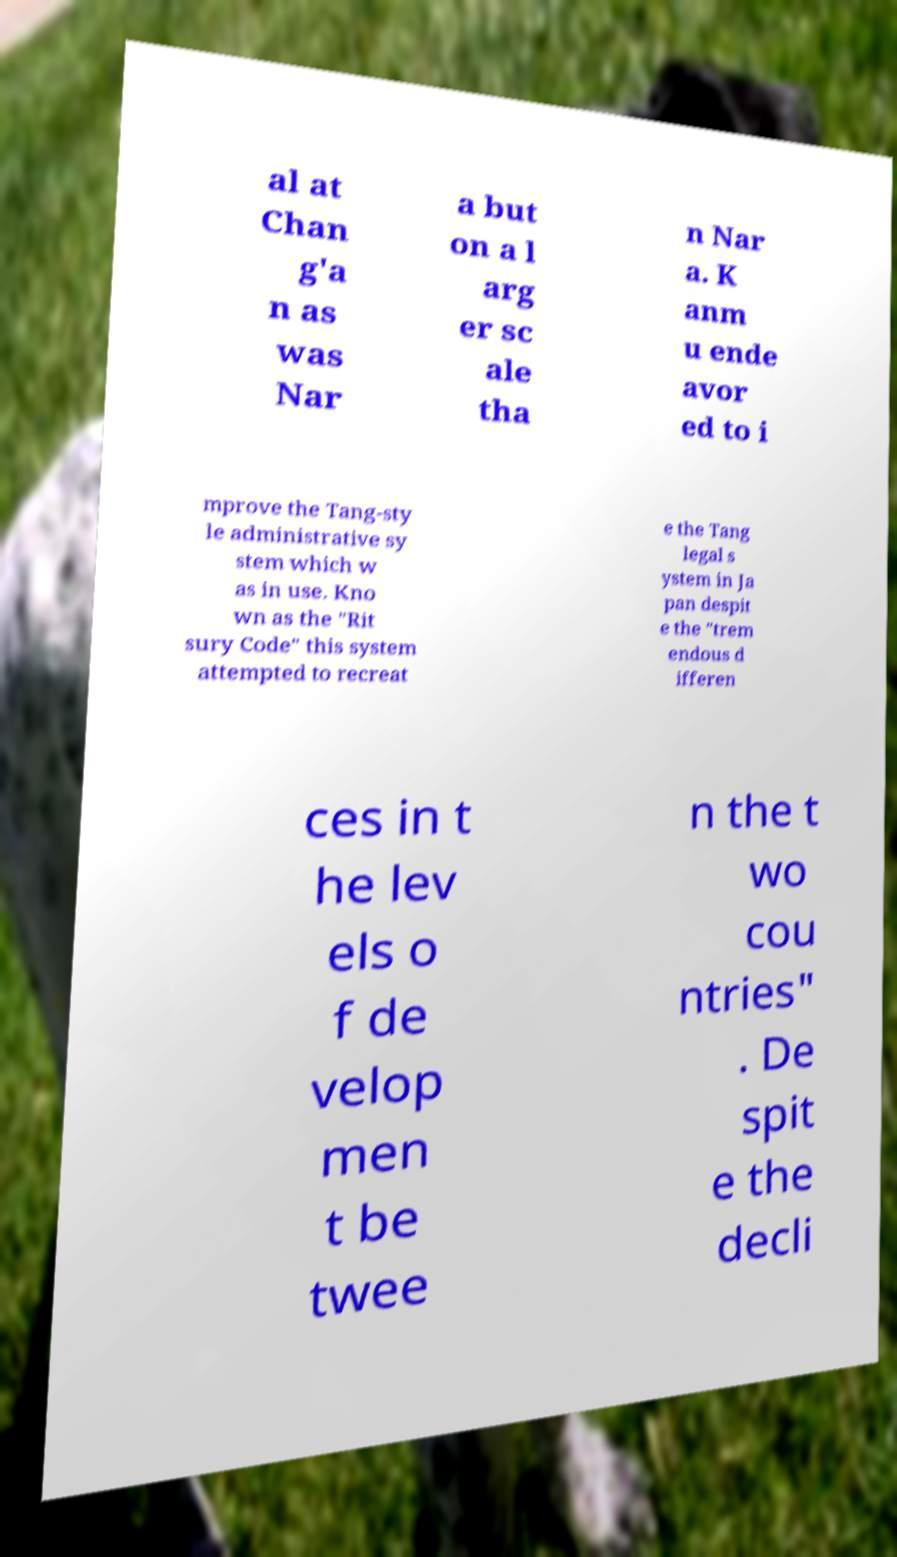Can you accurately transcribe the text from the provided image for me? al at Chan g'a n as was Nar a but on a l arg er sc ale tha n Nar a. K anm u ende avor ed to i mprove the Tang-sty le administrative sy stem which w as in use. Kno wn as the "Rit sury Code" this system attempted to recreat e the Tang legal s ystem in Ja pan despit e the "trem endous d ifferen ces in t he lev els o f de velop men t be twee n the t wo cou ntries" . De spit e the decli 